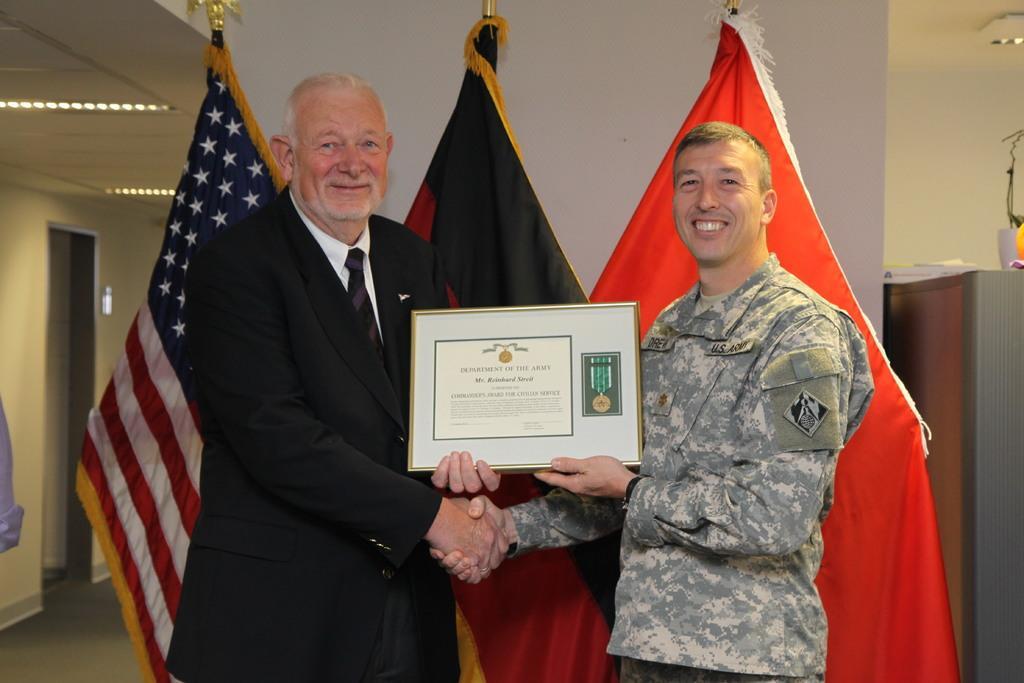Can you describe this image briefly? In this picture we can observe two men. Both of them are smiling, holding a frame in their hands. One of them is wearing a coat and a tie. Behind them there are three flags. In the background we can observe white color wall. 